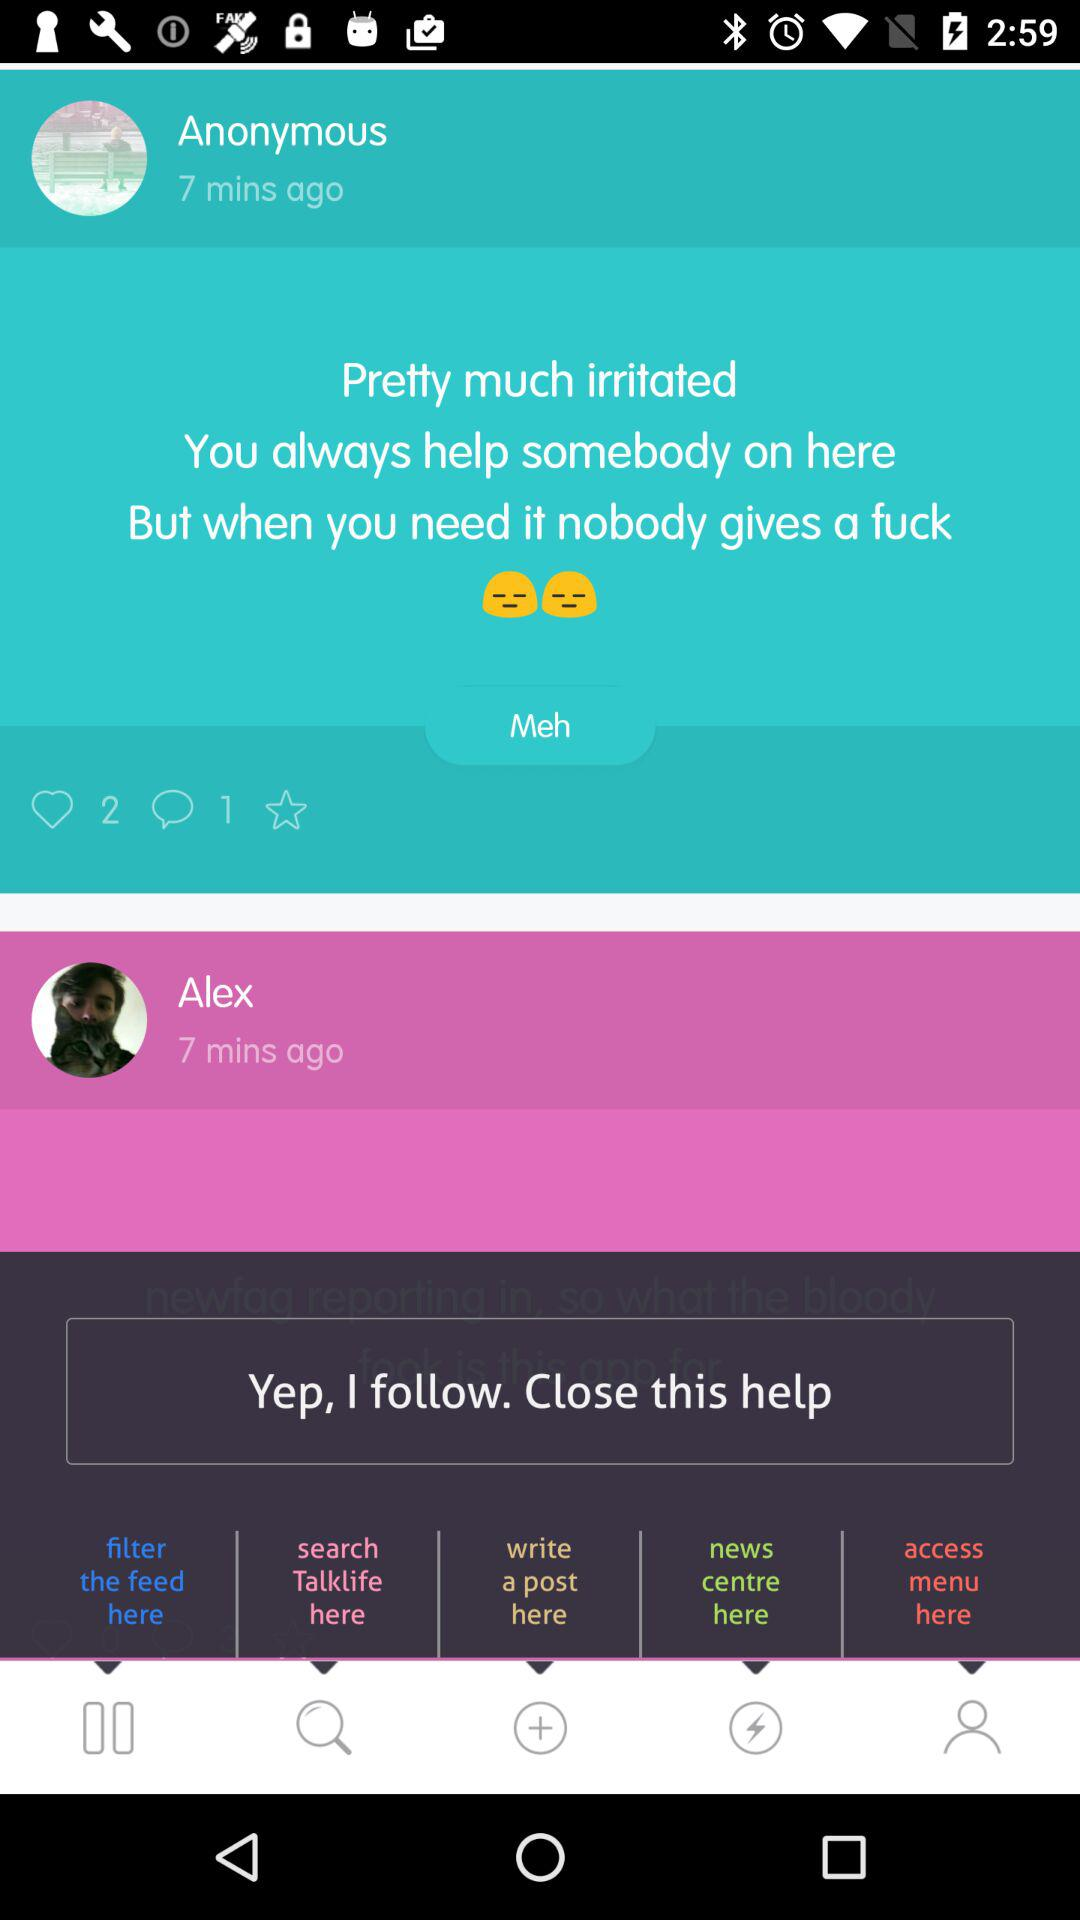When was Alex online? Alex was online 7 minutes ago. 